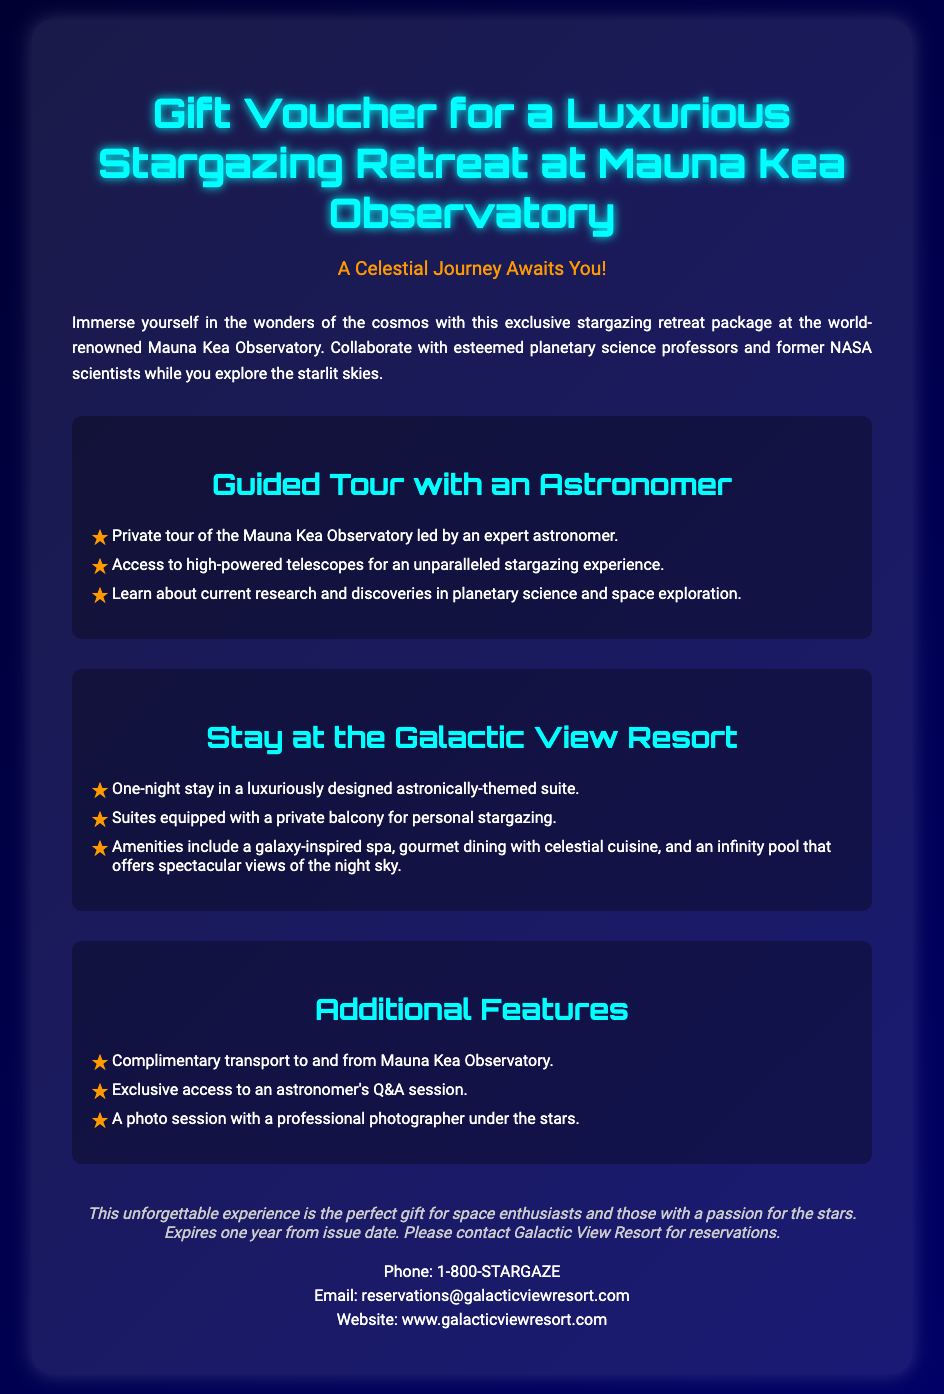What is the location of the stargazing retreat? The document states that the stargazing retreat is at Mauna Kea Observatory.
Answer: Mauna Kea Observatory Who leads the guided tour? The guided tour is led by an expert astronomer, as mentioned in the document.
Answer: expert astronomer What amenities are included in the Galactic View Resort stay? The document lists amenities such as a galaxy-inspired spa, gourmet dining, and an infinity pool.
Answer: galaxy-inspired spa, gourmet dining, infinity pool How long is the stay at the resort? The document specifies that the stay is for one night.
Answer: one night What type of session is offered with the astronomer? The document indicates there is an exclusive access to an astronomer's Q&A session.
Answer: Q&A session What is the validity period of the gift voucher? The document states that the gift voucher expires one year from the issue date.
Answer: one year 